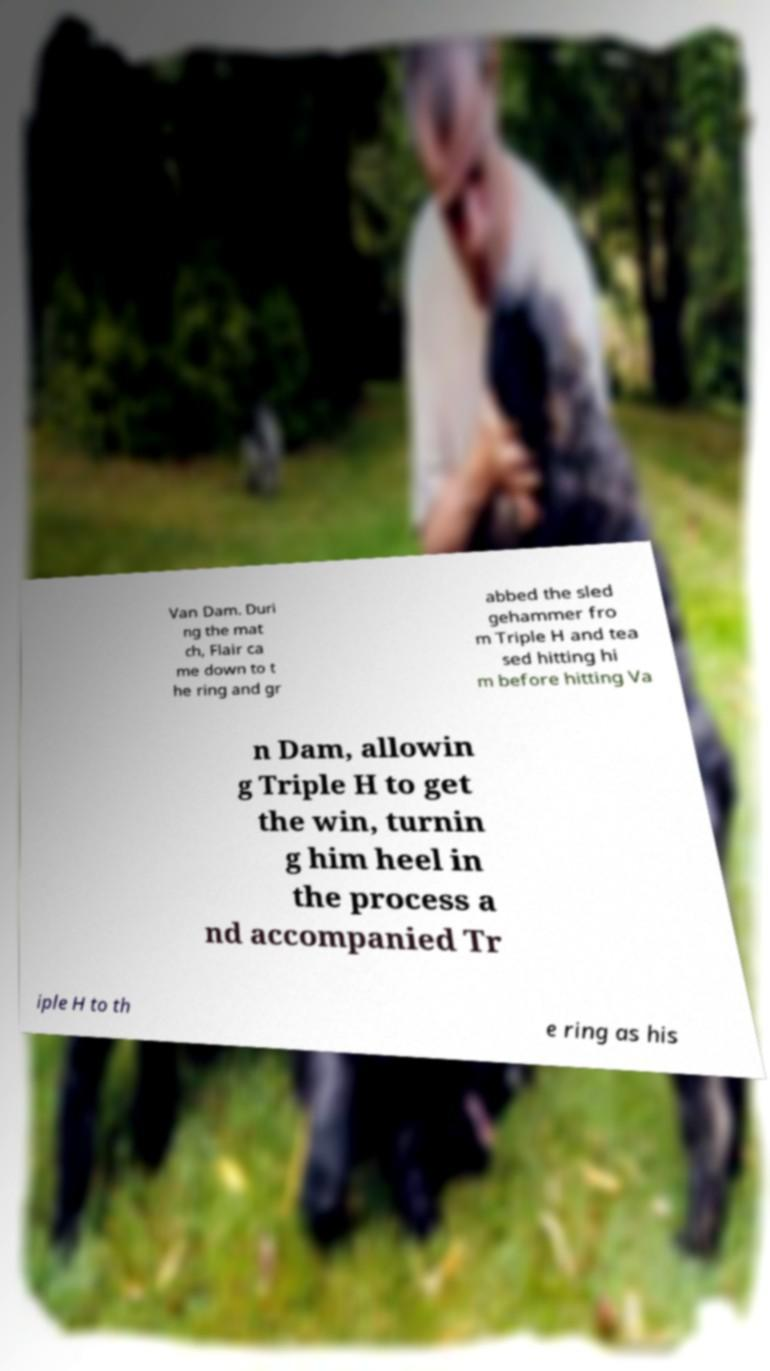For documentation purposes, I need the text within this image transcribed. Could you provide that? Van Dam. Duri ng the mat ch, Flair ca me down to t he ring and gr abbed the sled gehammer fro m Triple H and tea sed hitting hi m before hitting Va n Dam, allowin g Triple H to get the win, turnin g him heel in the process a nd accompanied Tr iple H to th e ring as his 